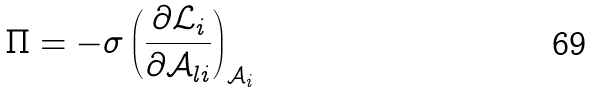<formula> <loc_0><loc_0><loc_500><loc_500>\Pi = - \sigma \left ( \frac { \partial \mathcal { L } _ { i } } { \partial \mathcal { A } _ { l i } } \right ) _ { \mathcal { A } _ { i } }</formula> 